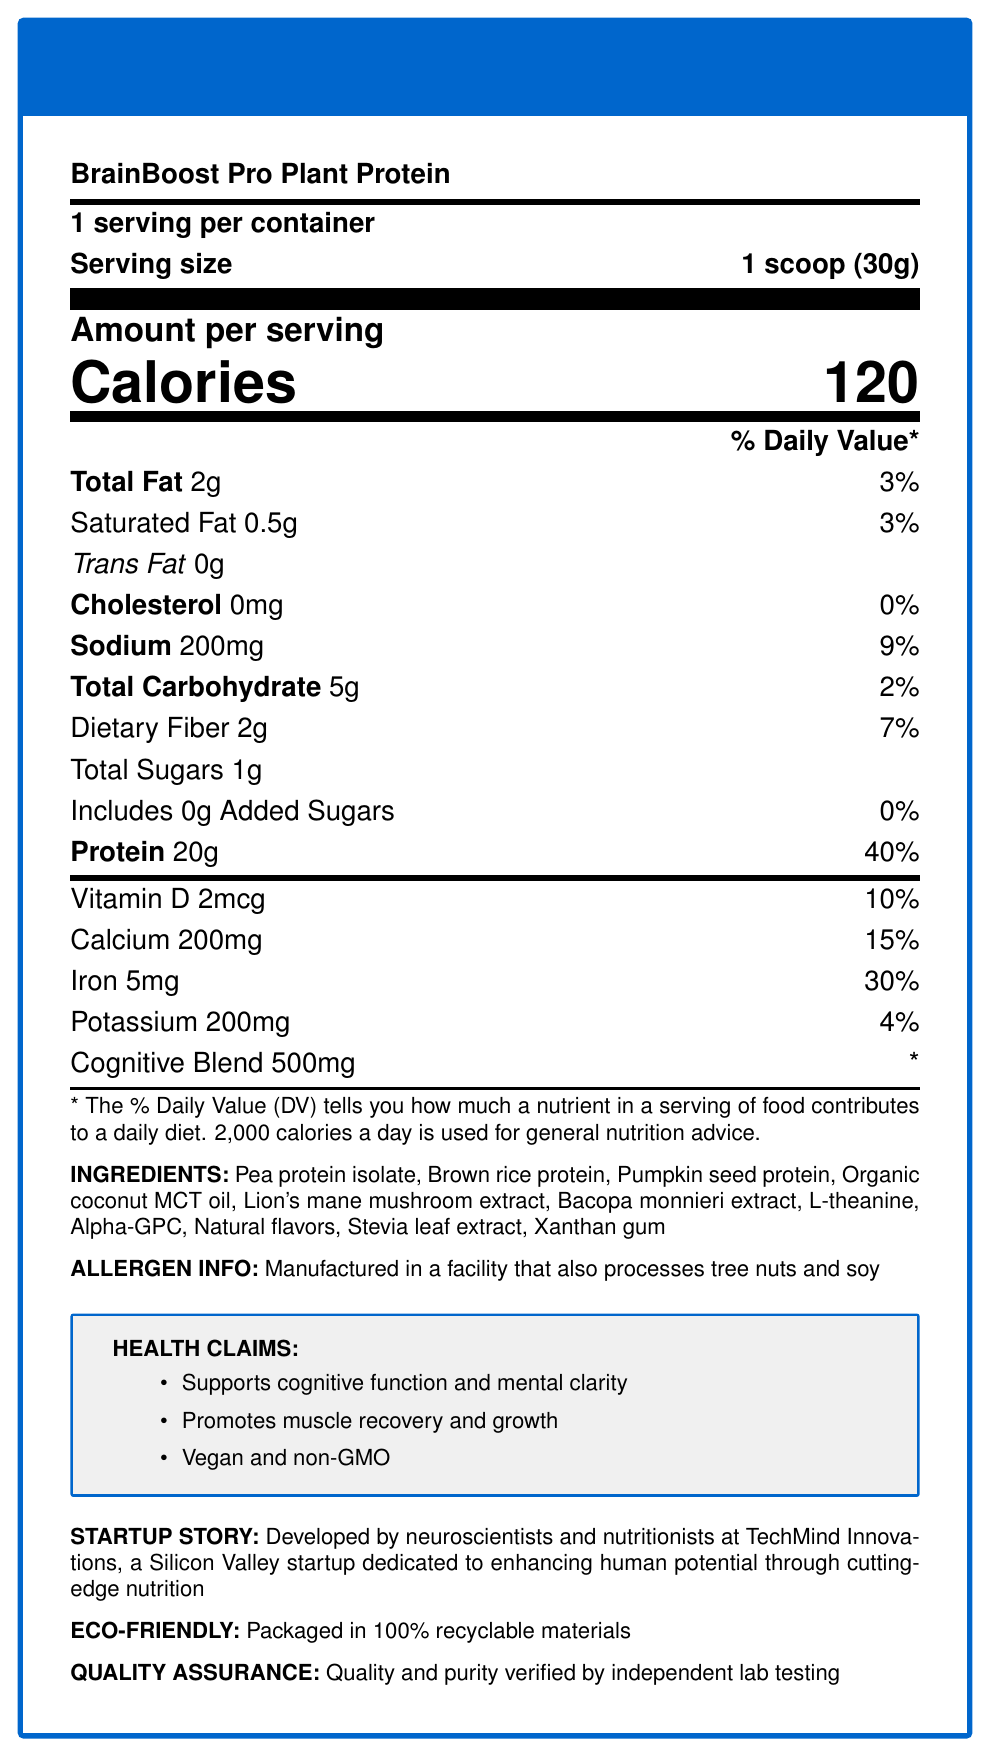what is the serving size? The document states that the serving size is "1 scoop (30g)."
Answer: 1 scoop (30g) How many servings are in the container? The document mentions that there are 15 servings per container.
Answer: 15 What is the total calorie count per serving? The document specifies that each serving has 120 calories.
Answer: 120 calories How much protein is in each serving? The document states that each serving contains 20g of protein.
Answer: 20g What ingredients are used in the cognitive blend? The document lists the cognitive blend ingredients as Lion's mane mushroom extract, Bacopa monnieri extract, L-theanine, and Alpha-GPC.
Answer: Lion's mane mushroom extract, Bacopa monnieri extract, L-theanine, Alpha-GPC What percentage of the daily value is provided by the iron in each serving? The document indicates that each serving provides 30% of the daily value for iron.
Answer: 30% Which of the following ingredients is NOT present in the product? A. Pea Protein Isolate B. Whey Protein C. Brown Rice Protein D. L-Theanine Whey Protein is not listed as an ingredient in the document.
Answer: B What claim is NOT made about the product? 1. Supports cognitive function 2. Promotes weight loss 3. Promotes muscle recovery 4. Vegan and non-GMO The claim that the product promotes weight loss is not made in the document.
Answer: 2 Is the product free of added sugars? The document specifies that there are 0g of added sugars in the product, thus it is free of added sugars.
Answer: Yes Summarize the main points of the document. The document provides detailed nutritional information, ingredients, health claims, allergen info, startup story, eco-friendliness, and quality assurance about BrainBoost Pro Plant Protein.
Answer: BrainBoost Pro Plant Protein is a plant-based protein shake that supports cognitive function and muscle recovery. It provides 20g of protein per serving with 120 calories. The product includes ingredients like pea protein isolate, brown rice protein, pumpkin seed protein, and a cognitive blend. It is vegan, non-GMO, and packaged in recyclable materials. How much dietary fiber does each serving contain? The document states each serving contains 2g of dietary fiber.
Answer: 2g In what way is the product environmentally friendly? The document mentions that the product is packaged in 100% recyclable materials, highlighting its eco-friendliness.
Answer: Packaged in 100% recyclable materials Where is the product manufactured? The document does not provide specific information about the manufacturing location of the product.
Answer: Not enough information 